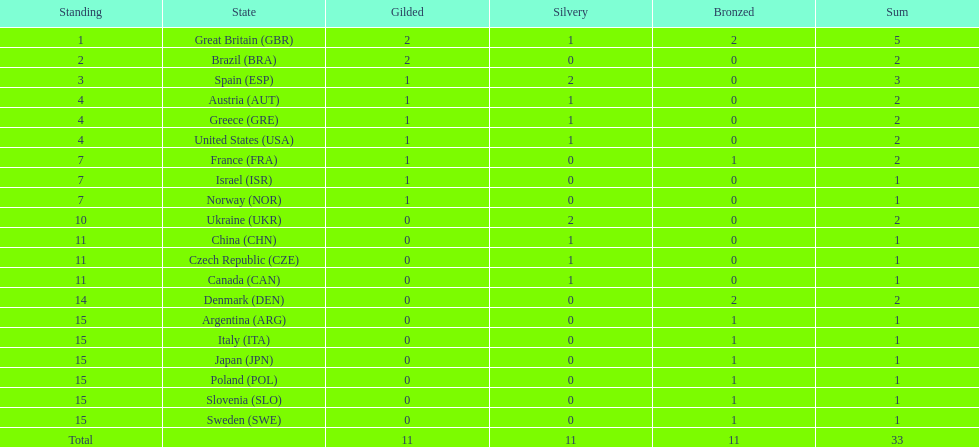What is the total number of gold medals awarded to italy? 0. 